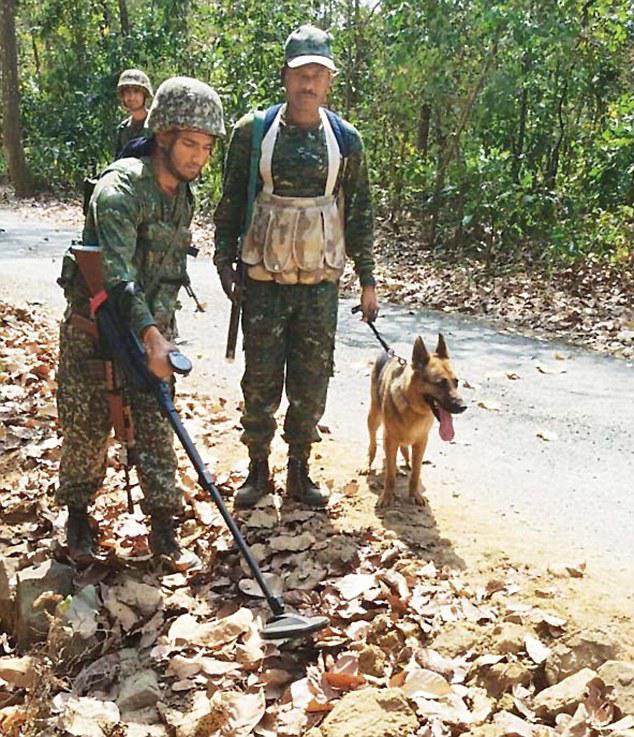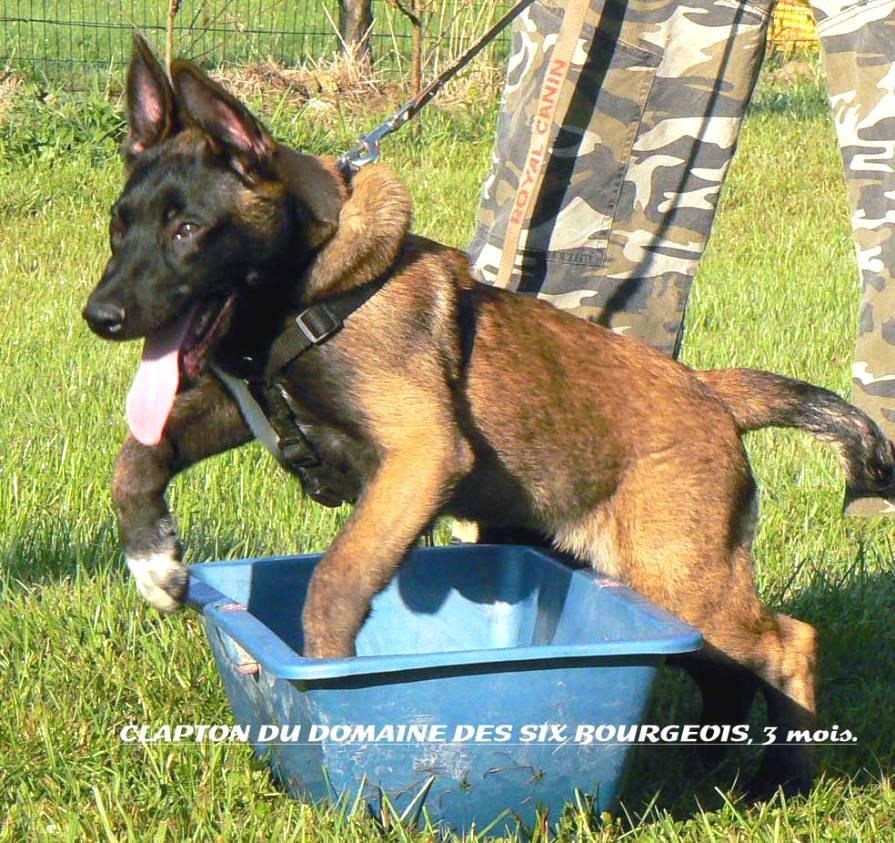The first image is the image on the left, the second image is the image on the right. Assess this claim about the two images: "There is a single human in the pair of images.". Correct or not? Answer yes or no. No. The first image is the image on the left, the second image is the image on the right. Considering the images on both sides, is "One image shows a german shepherd in a harness vest sitting upright, and the othe image shows a man in padded pants holding a stick near a dog." valid? Answer yes or no. No. 